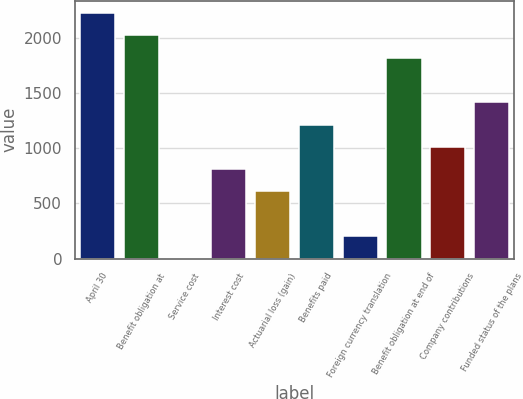Convert chart to OTSL. <chart><loc_0><loc_0><loc_500><loc_500><bar_chart><fcel>April 30<fcel>Benefit obligation at<fcel>Service cost<fcel>Interest cost<fcel>Actuarial loss (gain)<fcel>Benefits paid<fcel>Foreign currency translation<fcel>Benefit obligation at end of<fcel>Company contributions<fcel>Funded status of the plans<nl><fcel>2220.69<fcel>2019<fcel>2.1<fcel>808.86<fcel>607.17<fcel>1212.24<fcel>203.79<fcel>1817.31<fcel>1010.55<fcel>1413.93<nl></chart> 